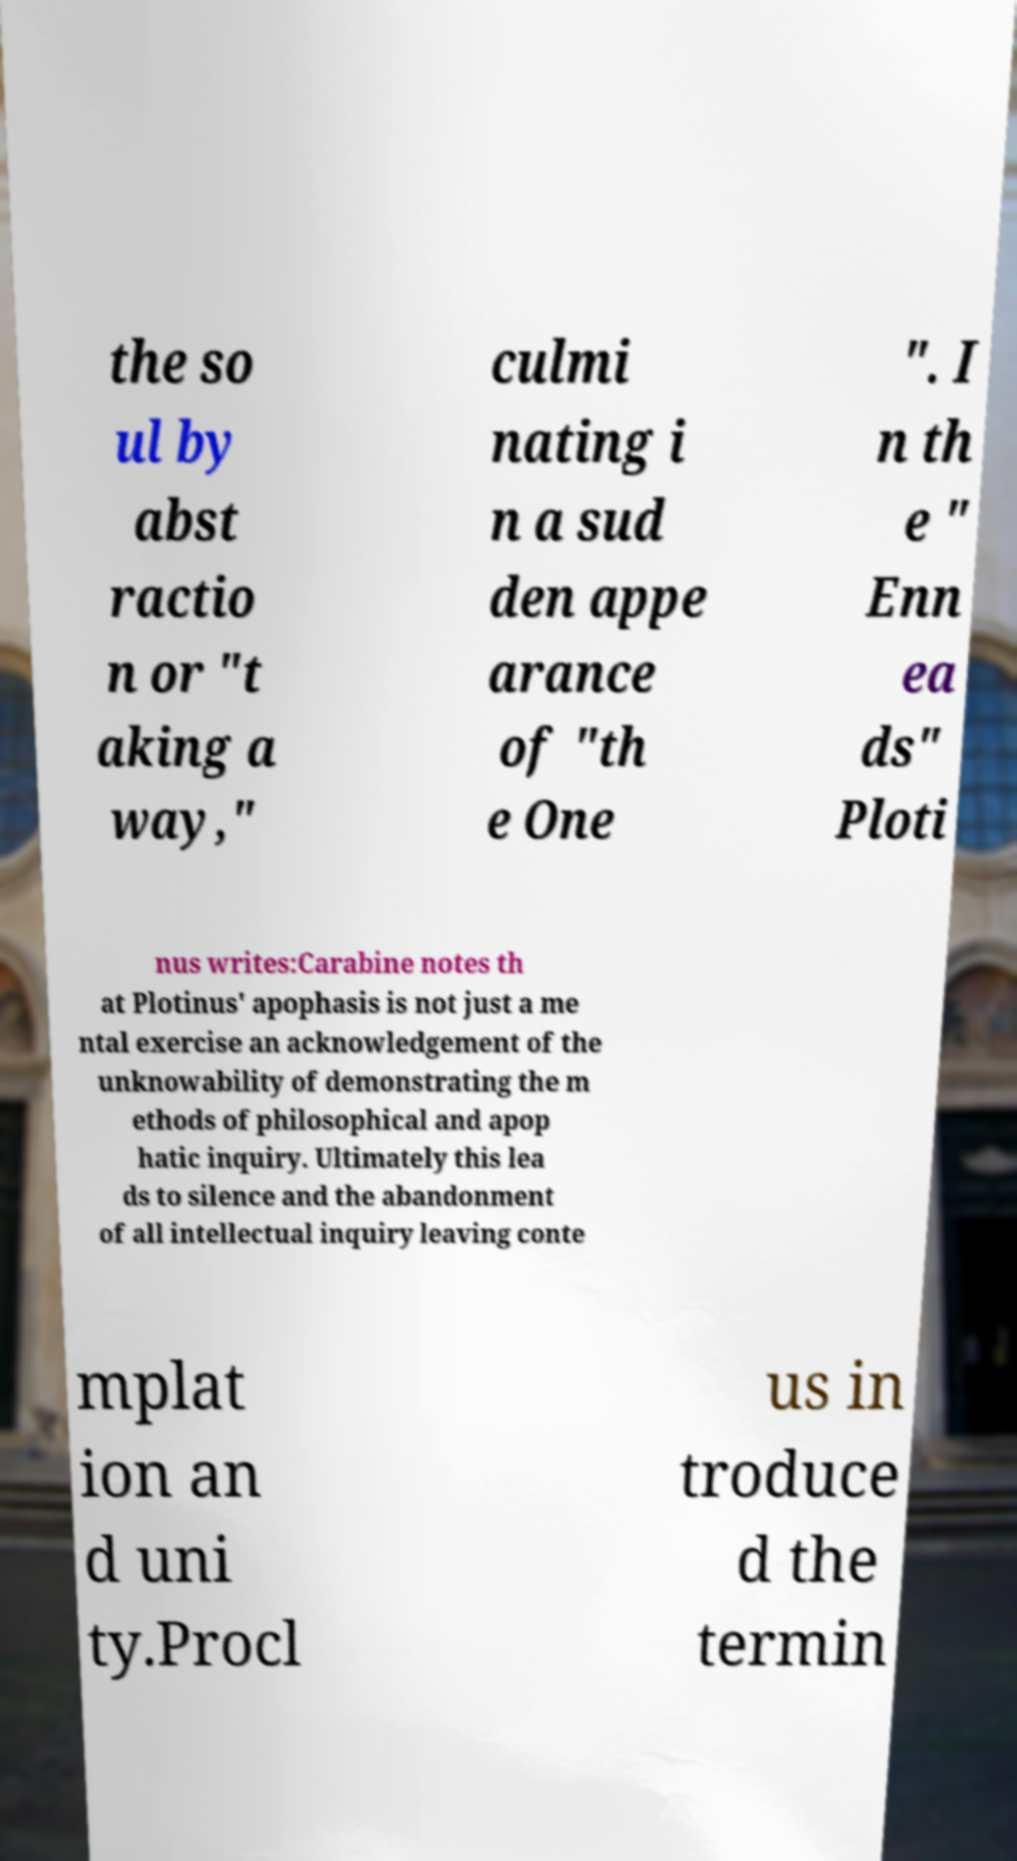What messages or text are displayed in this image? I need them in a readable, typed format. the so ul by abst ractio n or "t aking a way," culmi nating i n a sud den appe arance of "th e One ". I n th e " Enn ea ds" Ploti nus writes:Carabine notes th at Plotinus' apophasis is not just a me ntal exercise an acknowledgement of the unknowability of demonstrating the m ethods of philosophical and apop hatic inquiry. Ultimately this lea ds to silence and the abandonment of all intellectual inquiry leaving conte mplat ion an d uni ty.Procl us in troduce d the termin 